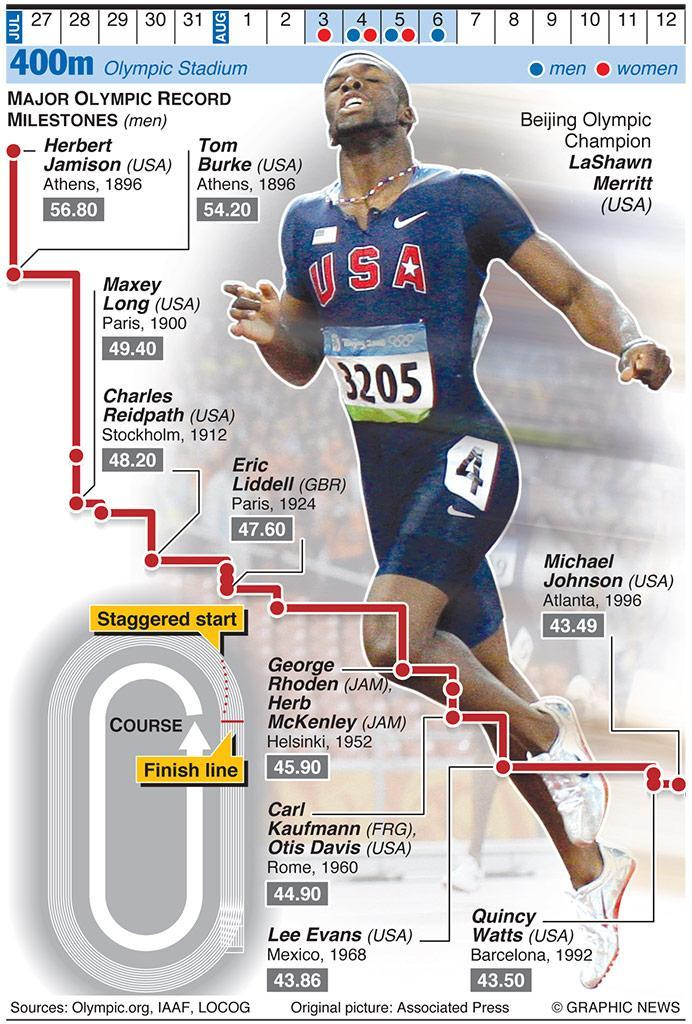Which US athlete set a record of 56.80 in the 400m race at the first Olympic games?
Answer the question with a short phrase. Herbert Jamison What was the record set by Tom Burke in 400m race at Athens in 1896? 54.20 What was the record achieved by George Rhoden in 400m race? 45.90 Which US athlete set a record of 43.49 in the 400m race in 1996? Michael Johnson Which US Athlete's photo is shown in the infographic? LaShawn Merritt Which US Olympic champion holds a record of 48.20 in 400m race? Charles Reidpath What was the record achieved by Carl Kaufmann in 400m race? 44.90 Which US athlete set a record of 43.86 at Mexico in 1968? Lee Evans What is the chest number of the athlete shown in the infographic? 3205 What was the record achieved by Quincy Watts in 400m race at Barcelona? 43.50 